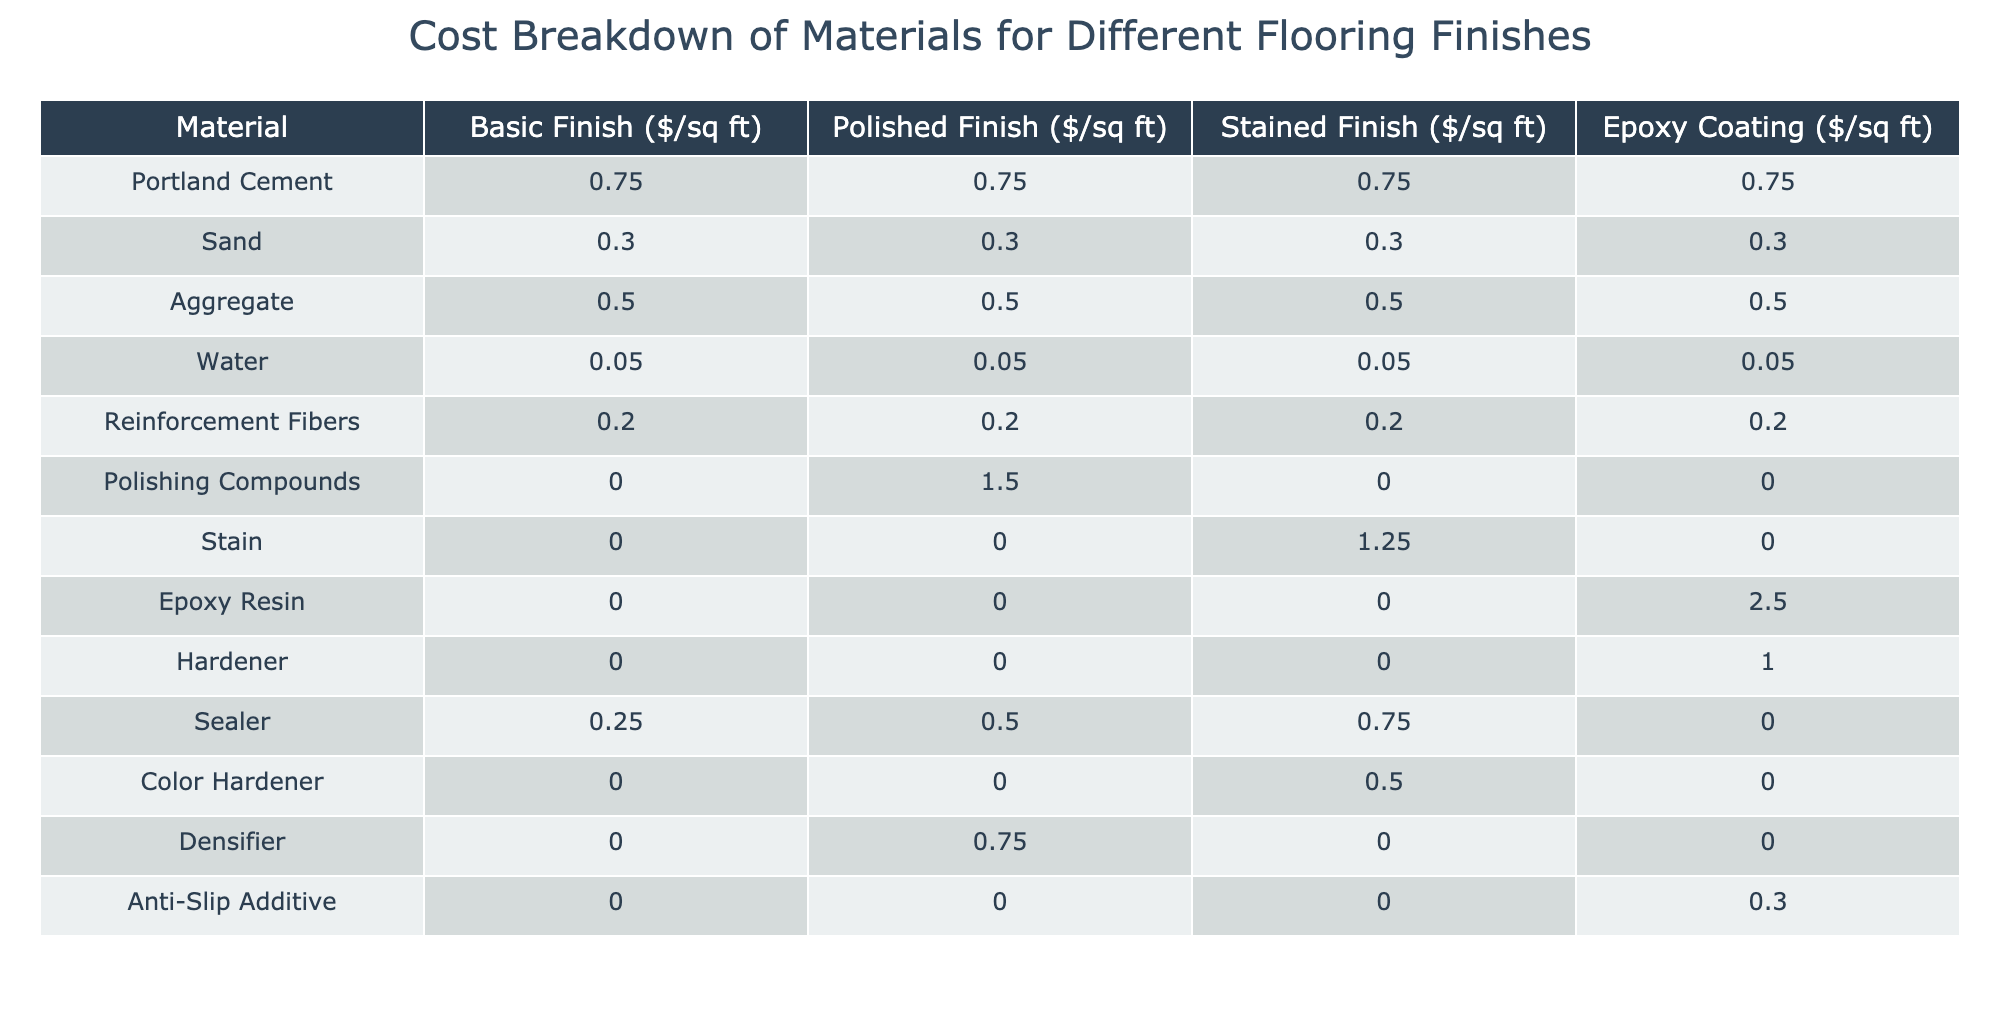What is the cost of Portland Cement for a Polished Finish? The table indicates that the price for Portland Cement in a Polished Finish is 0.75 per square foot.
Answer: 0.75 Which finish has the highest cost for Epoxy Resin? The table shows that Epoxy Resin costs 2.50 per square foot specifically for the Epoxy Coating finish.
Answer: Epoxy Coating What is the total cost of materials for a Basic Finish? To find this, we add the costs for all the materials under the Basic Finish category: 0.75 (Portland Cement) + 0.30 (Sand) + 0.50 (Aggregate) + 0.05 (Water) + 0.20 (Reinforcement Fibers) + 0.00 (Polishing Compounds) + 0.00 (Stain) + 0.00 (Epoxy Resin) + 0.00 (Hardener) + 0.25 (Sealer) + 0.00 (Color Hardener) + 0.00 (Densifier) + 0.00 (Anti-Slip Additive) = 1.80 per square foot.
Answer: 1.80 Does Stained Finish have any costs for Polishing Compounds? The table indicates that there is no cost for Polishing Compounds under the Stained Finish category, as it is listed as 0.00.
Answer: No What is the difference in cost between the Polished Finish and Epoxy Coating for Hardener? The cost for Hardener under the Polished Finish is 0.00, while for the Epoxy Coating it is 1.00. The difference is 1.00 - 0.00 = 1.00 per square foot.
Answer: 1.00 Which material has the highest cost for a Stained Finish? The highest cost material for a Stained Finish is Stain, priced at 1.25 per square foot, as indicated in the table.
Answer: Stain What is the average cost of materials for a Basic Finish? To find the average cost, we sum the costs for materials in the Basic Finish (1.80 as calculated earlier) and divide by the number of materials used (13). Thus, 1.80 / 12 = 0.15 per square foot.
Answer: 0.15 Is there a cost for Densifier in the Polished Finish? According to the table, the cost for Densifier in the Polished Finish is listed as 0.75. Therefore, there is a cost associated.
Answer: Yes How much does it cost to apply the Sealer in a Stained Finish compared to a Polished Finish? The cost for Sealer in the Stained Finish is 0.75, while in the Polished Finish it is 0.50. The difference is 0.75 - 0.50 = 0.25 per square foot, making it more expensive in Stained Finish.
Answer: 0.25 